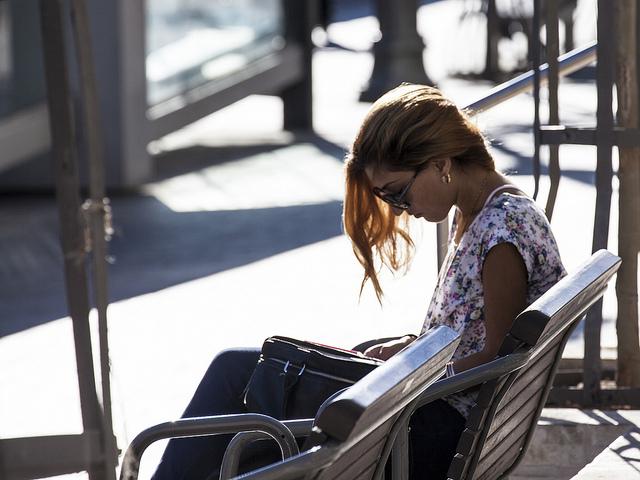Do you think this woman is waiting for a bus?
Short answer required. Yes. Is the woman wearing glasses?
Keep it brief. Yes. What color is the woman's purse?
Be succinct. Black. 